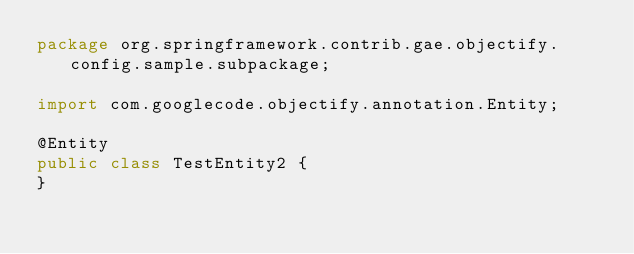Convert code to text. <code><loc_0><loc_0><loc_500><loc_500><_Java_>package org.springframework.contrib.gae.objectify.config.sample.subpackage;

import com.googlecode.objectify.annotation.Entity;

@Entity
public class TestEntity2 {
}
</code> 